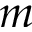<formula> <loc_0><loc_0><loc_500><loc_500>m</formula> 